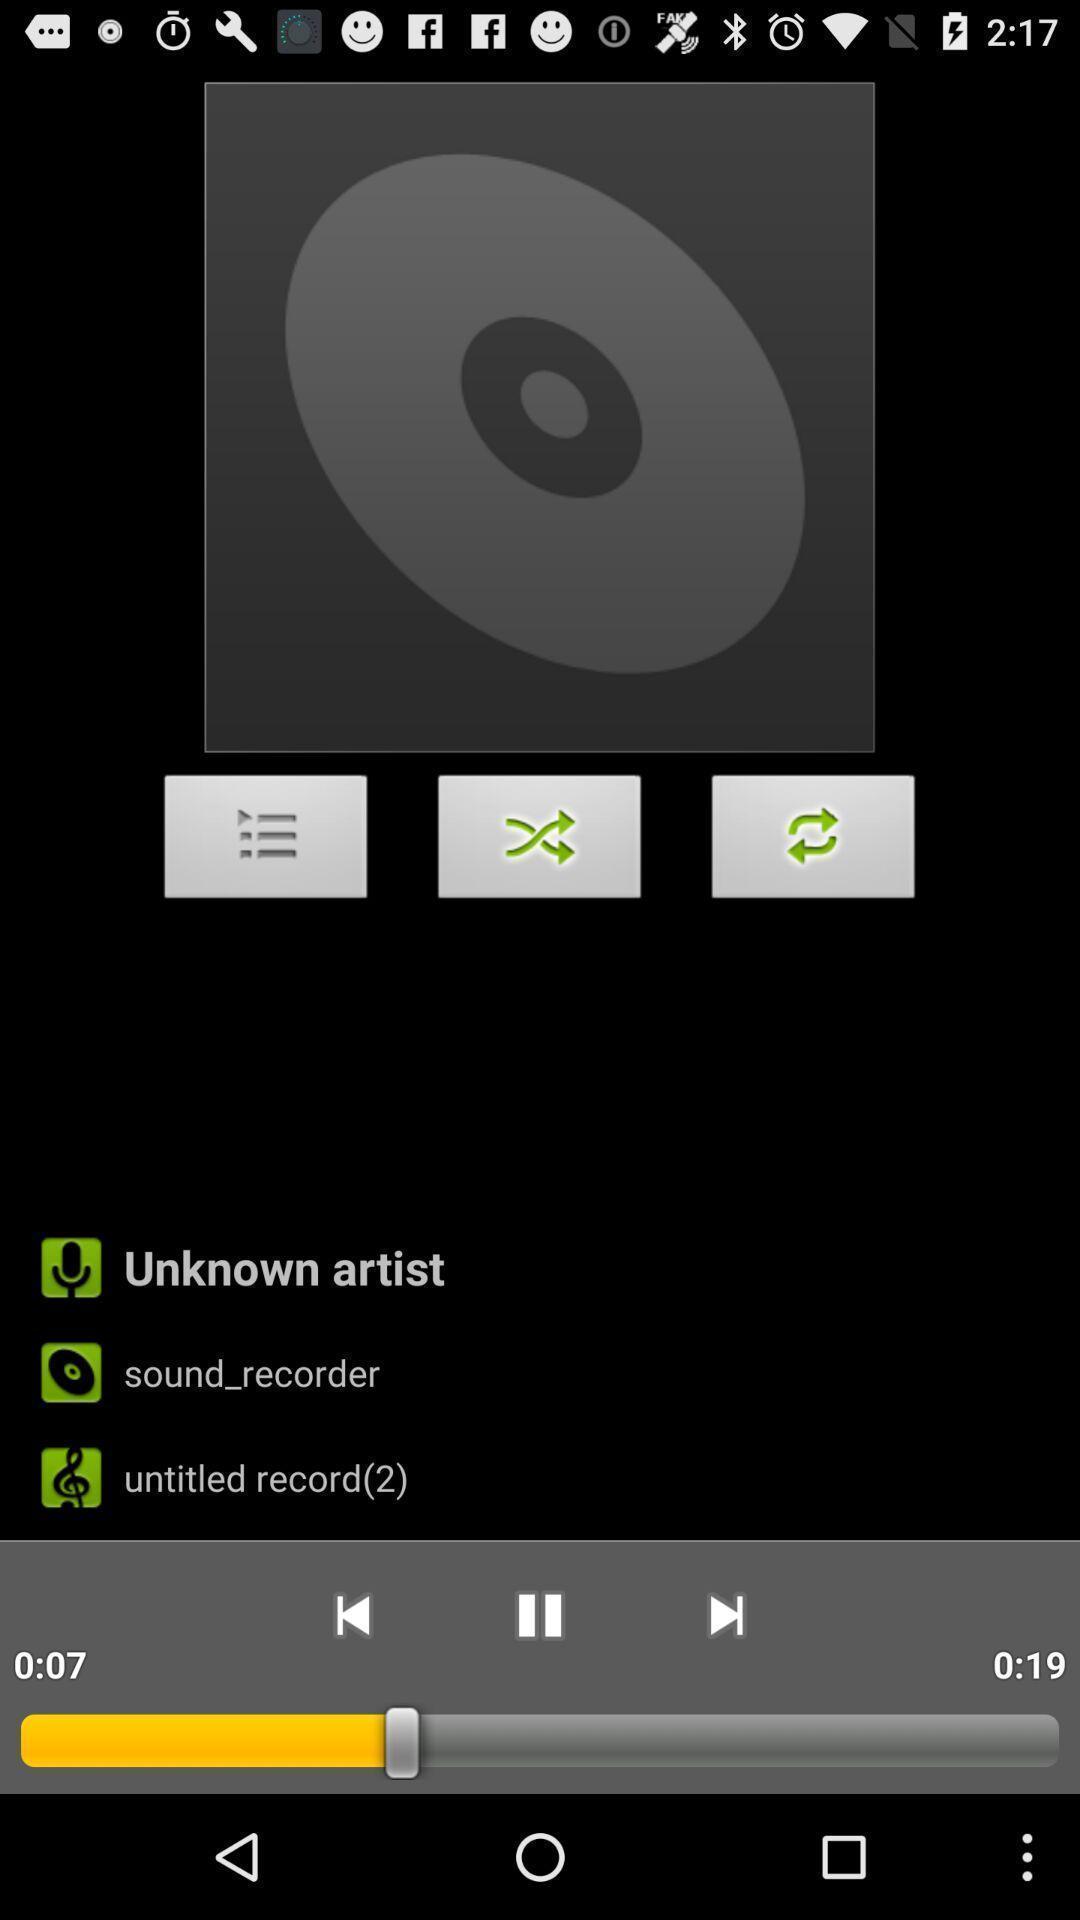Describe this image in words. Page shows to play song in music app. 